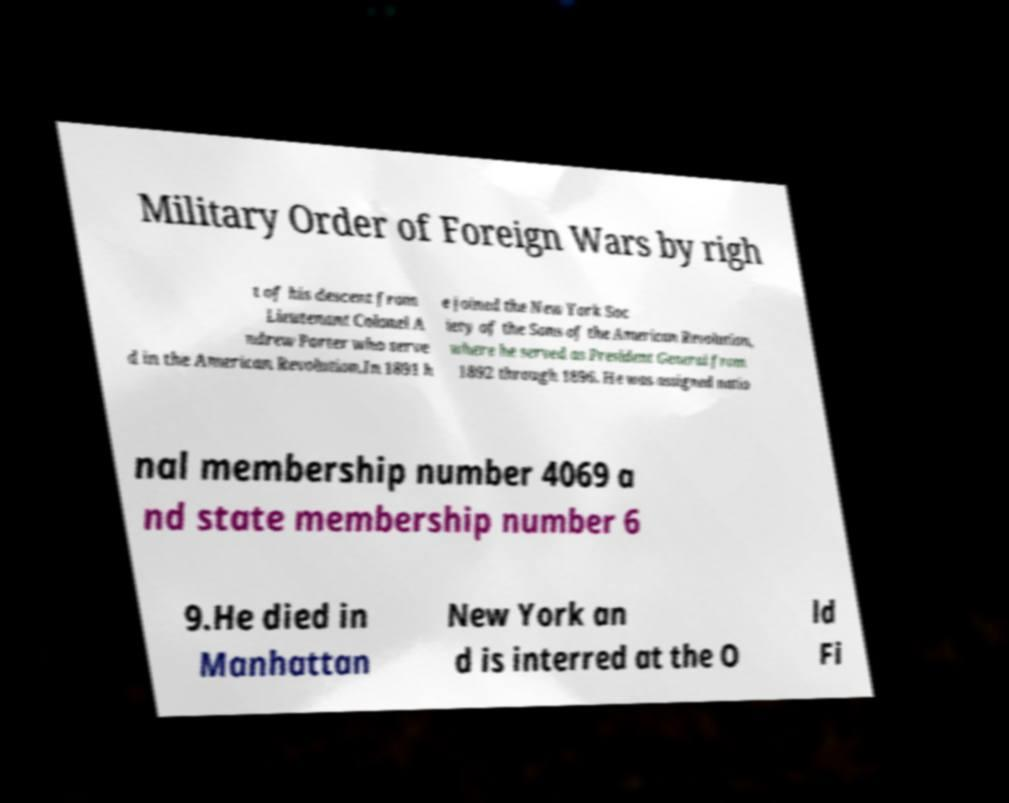Can you accurately transcribe the text from the provided image for me? Military Order of Foreign Wars by righ t of his descent from Lieutenant Colonel A ndrew Porter who serve d in the American Revolution.In 1891 h e joined the New York Soc iety of the Sons of the American Revolution, where he served as President General from 1892 through 1896. He was assigned natio nal membership number 4069 a nd state membership number 6 9.He died in Manhattan New York an d is interred at the O ld Fi 